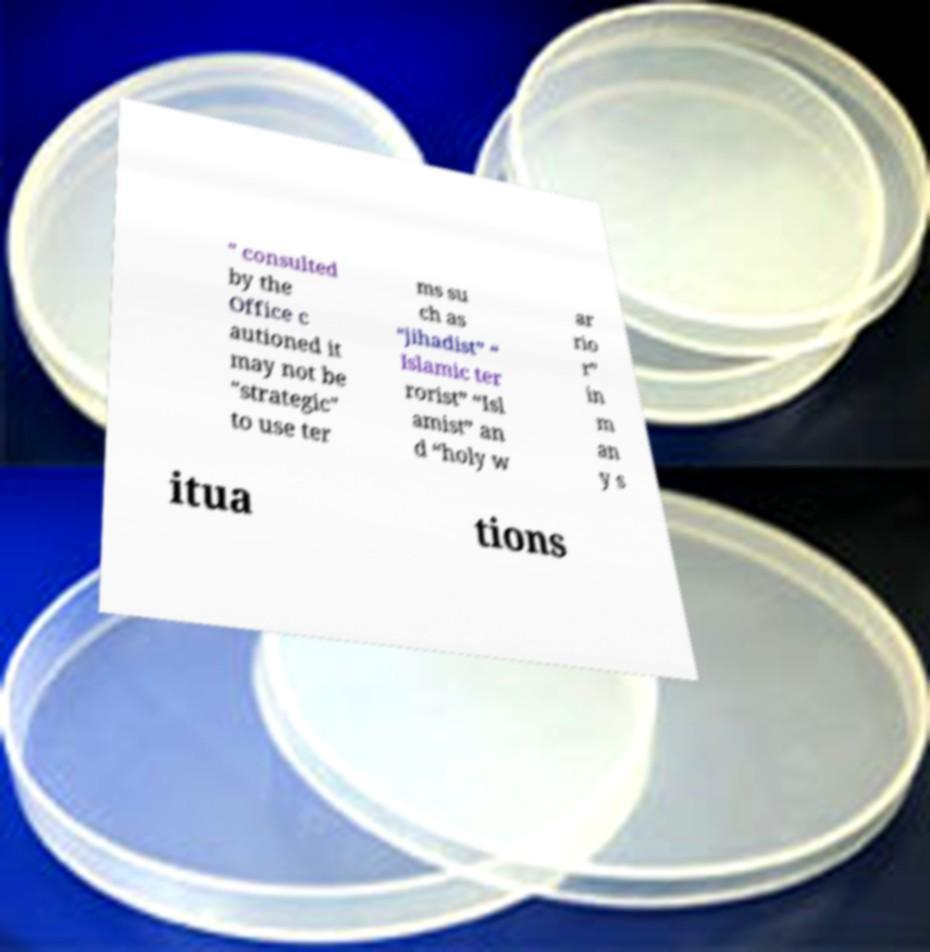Could you extract and type out the text from this image? " consulted by the Office c autioned it may not be "strategic" to use ter ms su ch as “jihadist” “ Islamic ter rorist” “Isl amist” an d “holy w ar rio r” in m an y s itua tions 